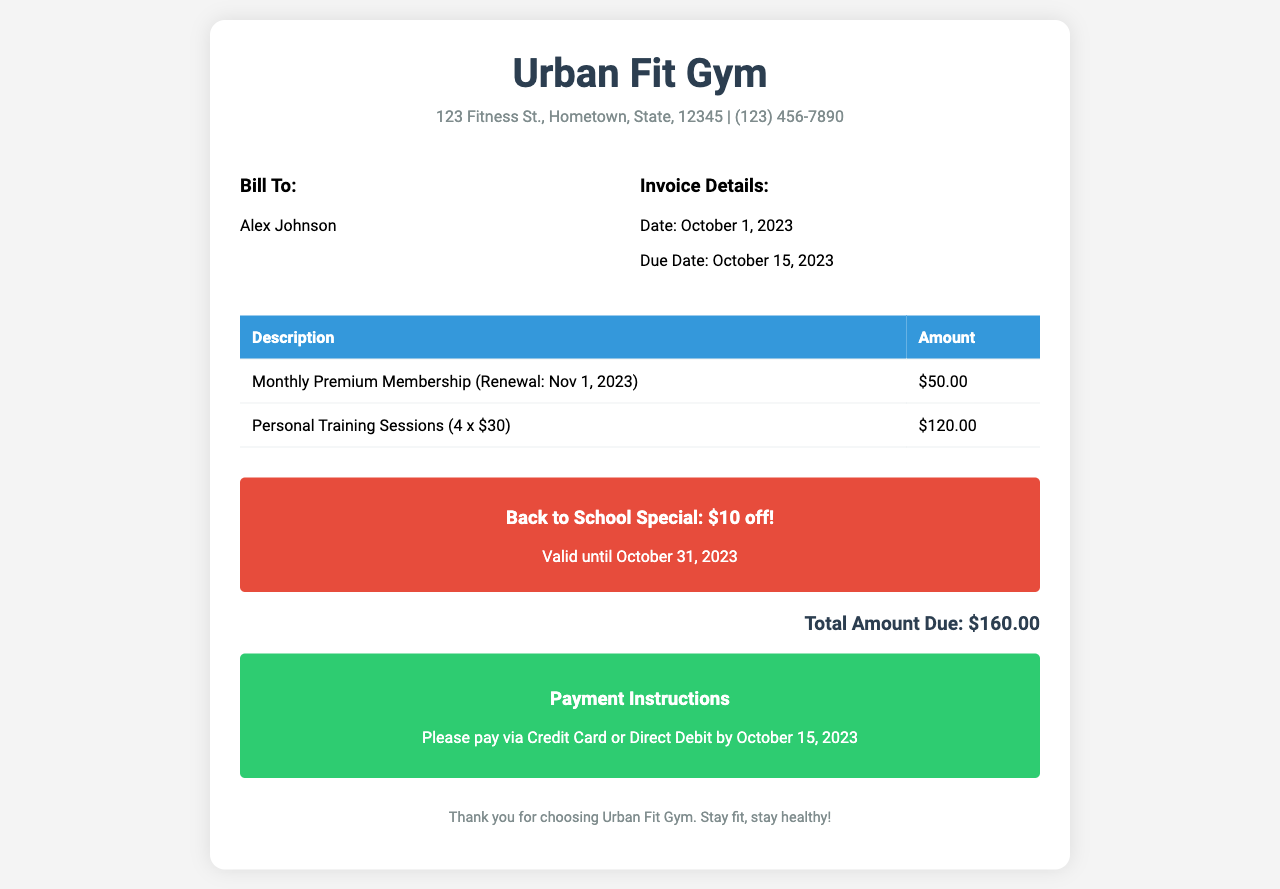What is the name of the gym? The gym's name is prominently displayed at the top of the invoice.
Answer: Urban Fit Gym Who is the invoice addressed to? The recipient's name is specified under the "Bill To" section.
Answer: Alex Johnson What is the total amount due? The total amount due is listed at the end of the invoice, summarizing all charges.
Answer: $160.00 What is the due date for the invoice? The due date is provided in the "Invoice Details" section.
Answer: October 15, 2023 How many personal training sessions were charged? The invoice details the number of training sessions under their description.
Answer: 4 What discount is mentioned in the promotional offer? The promotional offer clearly states the discount amount on the invoice.
Answer: $10 off When does the monthly premium membership renew? The renewal date for the membership is indicated in the description of the membership charge.
Answer: Nov 1, 2023 What payment methods are accepted? The payment instructions specify the methods available for payment.
Answer: Credit Card or Direct Debit What is the address of the gym? The gym's address is provided at the top of the invoice along with contact information.
Answer: 123 Fitness St., Hometown, State, 12345 